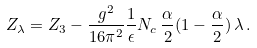Convert formula to latex. <formula><loc_0><loc_0><loc_500><loc_500>Z _ { \lambda } = Z _ { 3 } - \frac { g ^ { 2 } } { 1 6 \pi ^ { 2 } } \frac { 1 } { \epsilon } N _ { c } \, \frac { \alpha } { 2 } ( 1 - \frac { \alpha } { 2 } ) \, \lambda \, .</formula> 